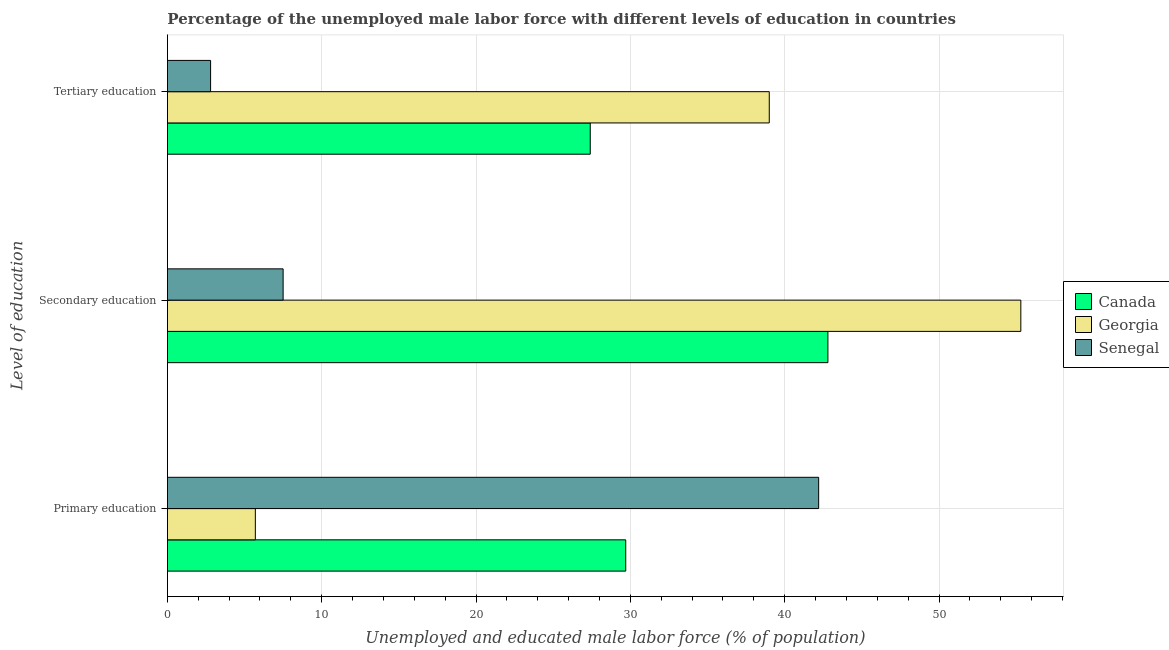How many different coloured bars are there?
Your answer should be compact. 3. How many groups of bars are there?
Give a very brief answer. 3. Are the number of bars per tick equal to the number of legend labels?
Offer a terse response. Yes. How many bars are there on the 3rd tick from the bottom?
Keep it short and to the point. 3. What is the label of the 1st group of bars from the top?
Your answer should be very brief. Tertiary education. What is the percentage of male labor force who received secondary education in Canada?
Keep it short and to the point. 42.8. Across all countries, what is the maximum percentage of male labor force who received tertiary education?
Keep it short and to the point. 39. In which country was the percentage of male labor force who received tertiary education maximum?
Provide a short and direct response. Georgia. In which country was the percentage of male labor force who received secondary education minimum?
Your answer should be very brief. Senegal. What is the total percentage of male labor force who received primary education in the graph?
Ensure brevity in your answer.  77.6. What is the difference between the percentage of male labor force who received tertiary education in Senegal and that in Canada?
Offer a very short reply. -24.6. What is the difference between the percentage of male labor force who received tertiary education in Georgia and the percentage of male labor force who received primary education in Canada?
Your answer should be very brief. 9.3. What is the average percentage of male labor force who received primary education per country?
Give a very brief answer. 25.87. What is the difference between the percentage of male labor force who received tertiary education and percentage of male labor force who received secondary education in Senegal?
Give a very brief answer. -4.7. What is the ratio of the percentage of male labor force who received primary education in Senegal to that in Canada?
Your answer should be compact. 1.42. Is the percentage of male labor force who received tertiary education in Canada less than that in Georgia?
Ensure brevity in your answer.  Yes. Is the difference between the percentage of male labor force who received secondary education in Canada and Georgia greater than the difference between the percentage of male labor force who received primary education in Canada and Georgia?
Offer a terse response. No. What is the difference between the highest and the second highest percentage of male labor force who received primary education?
Your answer should be compact. 12.5. What is the difference between the highest and the lowest percentage of male labor force who received tertiary education?
Keep it short and to the point. 36.2. Is the sum of the percentage of male labor force who received tertiary education in Georgia and Canada greater than the maximum percentage of male labor force who received primary education across all countries?
Provide a short and direct response. Yes. What does the 1st bar from the bottom in Primary education represents?
Offer a very short reply. Canada. What is the difference between two consecutive major ticks on the X-axis?
Give a very brief answer. 10. Does the graph contain grids?
Keep it short and to the point. Yes. Where does the legend appear in the graph?
Provide a short and direct response. Center right. How are the legend labels stacked?
Provide a short and direct response. Vertical. What is the title of the graph?
Your response must be concise. Percentage of the unemployed male labor force with different levels of education in countries. Does "Bahrain" appear as one of the legend labels in the graph?
Provide a succinct answer. No. What is the label or title of the X-axis?
Your response must be concise. Unemployed and educated male labor force (% of population). What is the label or title of the Y-axis?
Give a very brief answer. Level of education. What is the Unemployed and educated male labor force (% of population) of Canada in Primary education?
Keep it short and to the point. 29.7. What is the Unemployed and educated male labor force (% of population) of Georgia in Primary education?
Provide a short and direct response. 5.7. What is the Unemployed and educated male labor force (% of population) in Senegal in Primary education?
Your response must be concise. 42.2. What is the Unemployed and educated male labor force (% of population) of Canada in Secondary education?
Give a very brief answer. 42.8. What is the Unemployed and educated male labor force (% of population) in Georgia in Secondary education?
Offer a terse response. 55.3. What is the Unemployed and educated male labor force (% of population) in Senegal in Secondary education?
Provide a succinct answer. 7.5. What is the Unemployed and educated male labor force (% of population) of Canada in Tertiary education?
Ensure brevity in your answer.  27.4. What is the Unemployed and educated male labor force (% of population) of Georgia in Tertiary education?
Offer a very short reply. 39. What is the Unemployed and educated male labor force (% of population) of Senegal in Tertiary education?
Give a very brief answer. 2.8. Across all Level of education, what is the maximum Unemployed and educated male labor force (% of population) in Canada?
Provide a succinct answer. 42.8. Across all Level of education, what is the maximum Unemployed and educated male labor force (% of population) in Georgia?
Give a very brief answer. 55.3. Across all Level of education, what is the maximum Unemployed and educated male labor force (% of population) in Senegal?
Provide a short and direct response. 42.2. Across all Level of education, what is the minimum Unemployed and educated male labor force (% of population) of Canada?
Ensure brevity in your answer.  27.4. Across all Level of education, what is the minimum Unemployed and educated male labor force (% of population) in Georgia?
Your response must be concise. 5.7. Across all Level of education, what is the minimum Unemployed and educated male labor force (% of population) in Senegal?
Give a very brief answer. 2.8. What is the total Unemployed and educated male labor force (% of population) of Canada in the graph?
Your response must be concise. 99.9. What is the total Unemployed and educated male labor force (% of population) of Georgia in the graph?
Keep it short and to the point. 100. What is the total Unemployed and educated male labor force (% of population) of Senegal in the graph?
Give a very brief answer. 52.5. What is the difference between the Unemployed and educated male labor force (% of population) of Canada in Primary education and that in Secondary education?
Offer a very short reply. -13.1. What is the difference between the Unemployed and educated male labor force (% of population) of Georgia in Primary education and that in Secondary education?
Your answer should be very brief. -49.6. What is the difference between the Unemployed and educated male labor force (% of population) in Senegal in Primary education and that in Secondary education?
Provide a succinct answer. 34.7. What is the difference between the Unemployed and educated male labor force (% of population) in Georgia in Primary education and that in Tertiary education?
Offer a very short reply. -33.3. What is the difference between the Unemployed and educated male labor force (% of population) of Senegal in Primary education and that in Tertiary education?
Give a very brief answer. 39.4. What is the difference between the Unemployed and educated male labor force (% of population) in Georgia in Secondary education and that in Tertiary education?
Provide a short and direct response. 16.3. What is the difference between the Unemployed and educated male labor force (% of population) of Senegal in Secondary education and that in Tertiary education?
Your response must be concise. 4.7. What is the difference between the Unemployed and educated male labor force (% of population) in Canada in Primary education and the Unemployed and educated male labor force (% of population) in Georgia in Secondary education?
Ensure brevity in your answer.  -25.6. What is the difference between the Unemployed and educated male labor force (% of population) of Canada in Primary education and the Unemployed and educated male labor force (% of population) of Georgia in Tertiary education?
Your response must be concise. -9.3. What is the difference between the Unemployed and educated male labor force (% of population) in Canada in Primary education and the Unemployed and educated male labor force (% of population) in Senegal in Tertiary education?
Make the answer very short. 26.9. What is the difference between the Unemployed and educated male labor force (% of population) of Georgia in Secondary education and the Unemployed and educated male labor force (% of population) of Senegal in Tertiary education?
Keep it short and to the point. 52.5. What is the average Unemployed and educated male labor force (% of population) of Canada per Level of education?
Your response must be concise. 33.3. What is the average Unemployed and educated male labor force (% of population) in Georgia per Level of education?
Offer a very short reply. 33.33. What is the difference between the Unemployed and educated male labor force (% of population) of Canada and Unemployed and educated male labor force (% of population) of Georgia in Primary education?
Offer a terse response. 24. What is the difference between the Unemployed and educated male labor force (% of population) in Canada and Unemployed and educated male labor force (% of population) in Senegal in Primary education?
Provide a short and direct response. -12.5. What is the difference between the Unemployed and educated male labor force (% of population) in Georgia and Unemployed and educated male labor force (% of population) in Senegal in Primary education?
Offer a terse response. -36.5. What is the difference between the Unemployed and educated male labor force (% of population) of Canada and Unemployed and educated male labor force (% of population) of Georgia in Secondary education?
Offer a very short reply. -12.5. What is the difference between the Unemployed and educated male labor force (% of population) in Canada and Unemployed and educated male labor force (% of population) in Senegal in Secondary education?
Your response must be concise. 35.3. What is the difference between the Unemployed and educated male labor force (% of population) in Georgia and Unemployed and educated male labor force (% of population) in Senegal in Secondary education?
Make the answer very short. 47.8. What is the difference between the Unemployed and educated male labor force (% of population) of Canada and Unemployed and educated male labor force (% of population) of Senegal in Tertiary education?
Offer a terse response. 24.6. What is the difference between the Unemployed and educated male labor force (% of population) in Georgia and Unemployed and educated male labor force (% of population) in Senegal in Tertiary education?
Give a very brief answer. 36.2. What is the ratio of the Unemployed and educated male labor force (% of population) of Canada in Primary education to that in Secondary education?
Your answer should be very brief. 0.69. What is the ratio of the Unemployed and educated male labor force (% of population) of Georgia in Primary education to that in Secondary education?
Your response must be concise. 0.1. What is the ratio of the Unemployed and educated male labor force (% of population) in Senegal in Primary education to that in Secondary education?
Provide a succinct answer. 5.63. What is the ratio of the Unemployed and educated male labor force (% of population) in Canada in Primary education to that in Tertiary education?
Your answer should be very brief. 1.08. What is the ratio of the Unemployed and educated male labor force (% of population) of Georgia in Primary education to that in Tertiary education?
Offer a terse response. 0.15. What is the ratio of the Unemployed and educated male labor force (% of population) of Senegal in Primary education to that in Tertiary education?
Your response must be concise. 15.07. What is the ratio of the Unemployed and educated male labor force (% of population) of Canada in Secondary education to that in Tertiary education?
Your response must be concise. 1.56. What is the ratio of the Unemployed and educated male labor force (% of population) of Georgia in Secondary education to that in Tertiary education?
Your response must be concise. 1.42. What is the ratio of the Unemployed and educated male labor force (% of population) of Senegal in Secondary education to that in Tertiary education?
Ensure brevity in your answer.  2.68. What is the difference between the highest and the second highest Unemployed and educated male labor force (% of population) of Senegal?
Keep it short and to the point. 34.7. What is the difference between the highest and the lowest Unemployed and educated male labor force (% of population) in Georgia?
Your response must be concise. 49.6. What is the difference between the highest and the lowest Unemployed and educated male labor force (% of population) of Senegal?
Offer a very short reply. 39.4. 